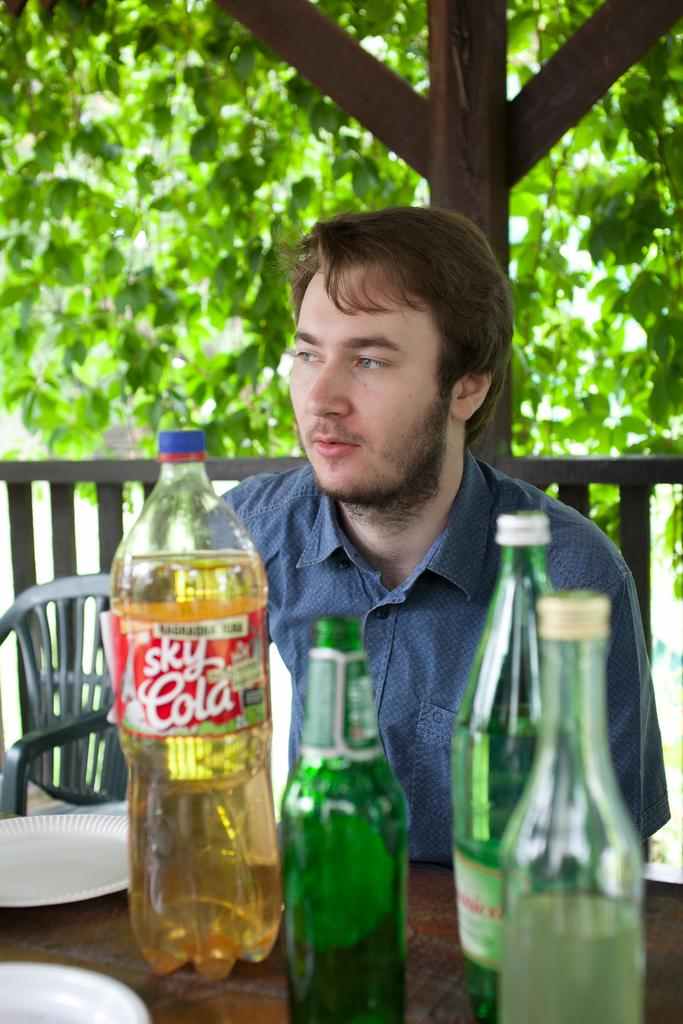Who is present in the image? There is a man in the image. What is the man doing in the image? The man is sitting on a chair. What is on the table in front of the man? There is a beer bottle and another bottle on the table. What can be seen in the background of the image? There are trees in the background of the image. What type of quartz is the governor holding in the image? There is no governor or quartz present in the image. What color is the coat the man is wearing in the image? The man is not wearing a coat in the image; he is sitting on a chair with a table in front of him. 